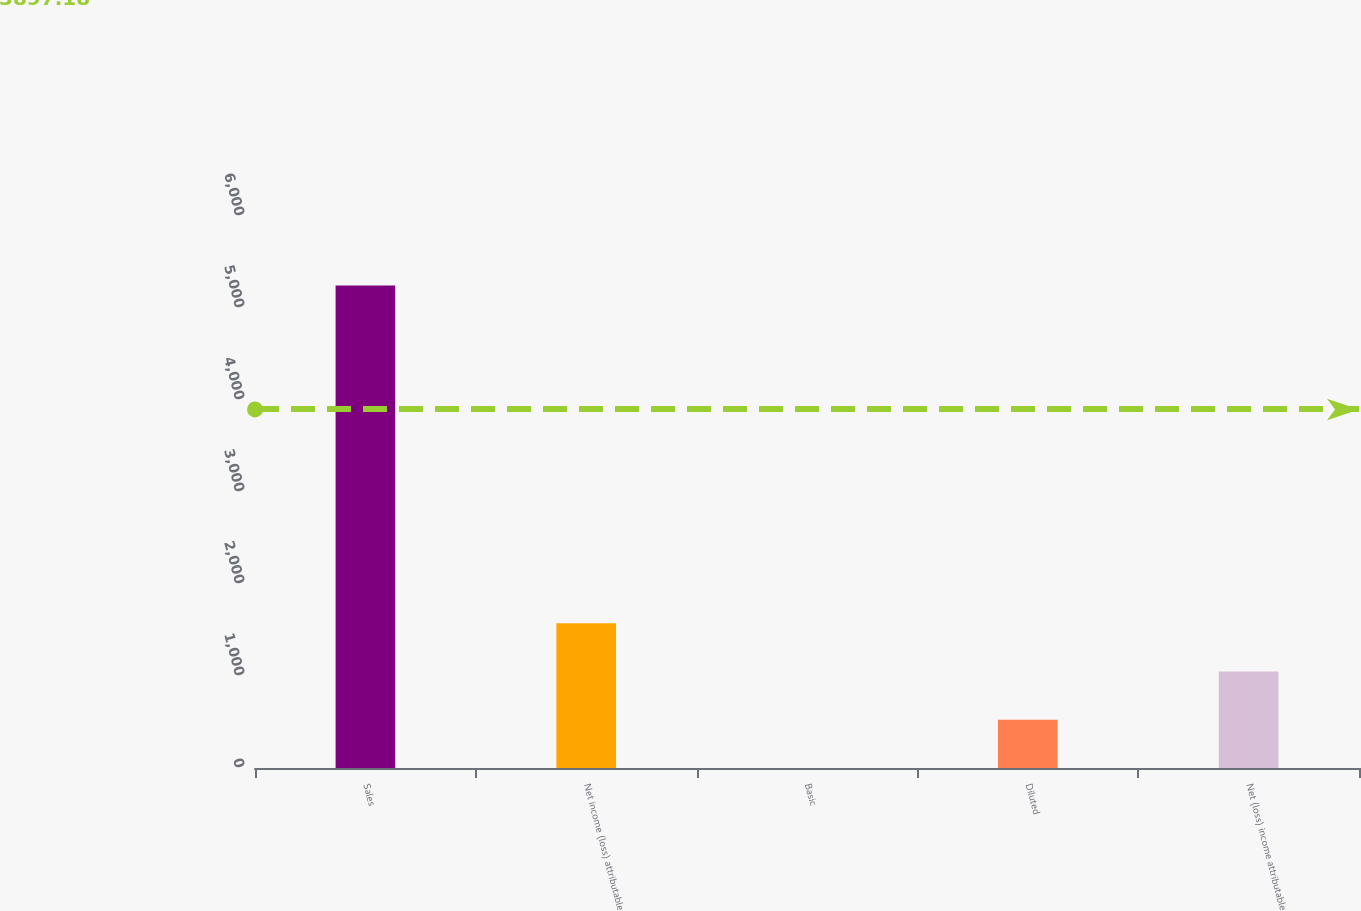<chart> <loc_0><loc_0><loc_500><loc_500><bar_chart><fcel>Sales<fcel>Net income (loss) attributable<fcel>Basic<fcel>Diluted<fcel>Net (loss) income attributable<nl><fcel>5245<fcel>1573.89<fcel>0.55<fcel>525<fcel>1049.45<nl></chart> 